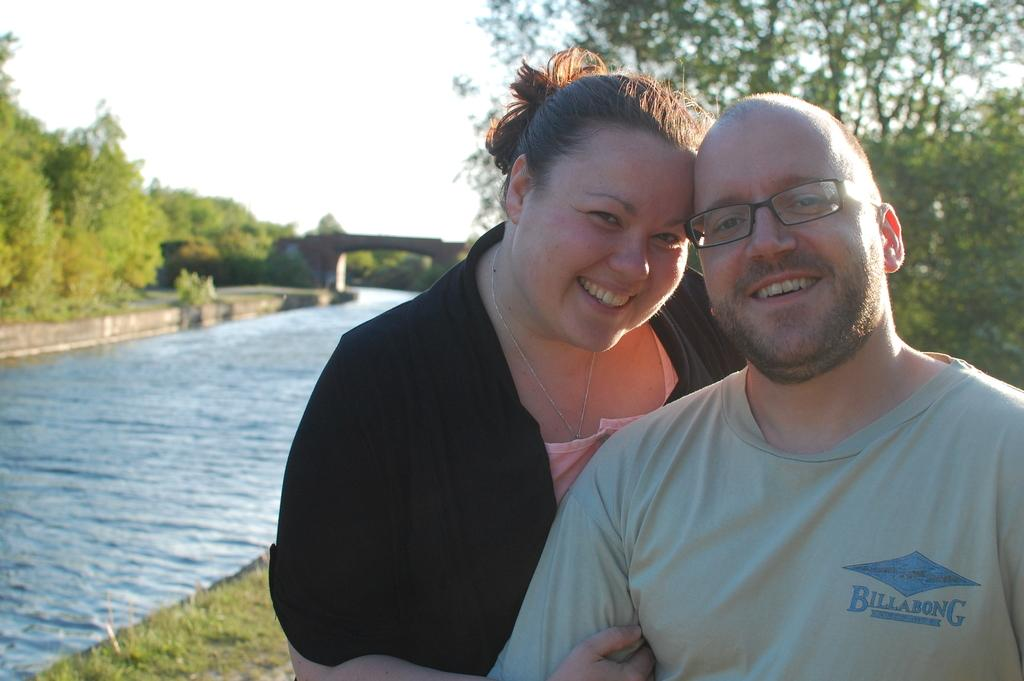How many people are present in the image? There are two people, a man and a woman, present in the image. What are the expressions of the people in the image? Both the man and the woman are smiling in the image. What is the man wearing in the image? The man is wearing spectacles in the image. What can be seen in the background of the image? There is water, a bridge, trees, and a cloudy sky visible in the image. What is the ground covered with in the image? There is grass on the ground in the image. What type of camera can be seen in the image? There is no camera present in the image. What sport are the people playing in the image? There is no sport being played in the image, as it features a man and a woman smiling near a body of water with a bridge and trees in the background. 